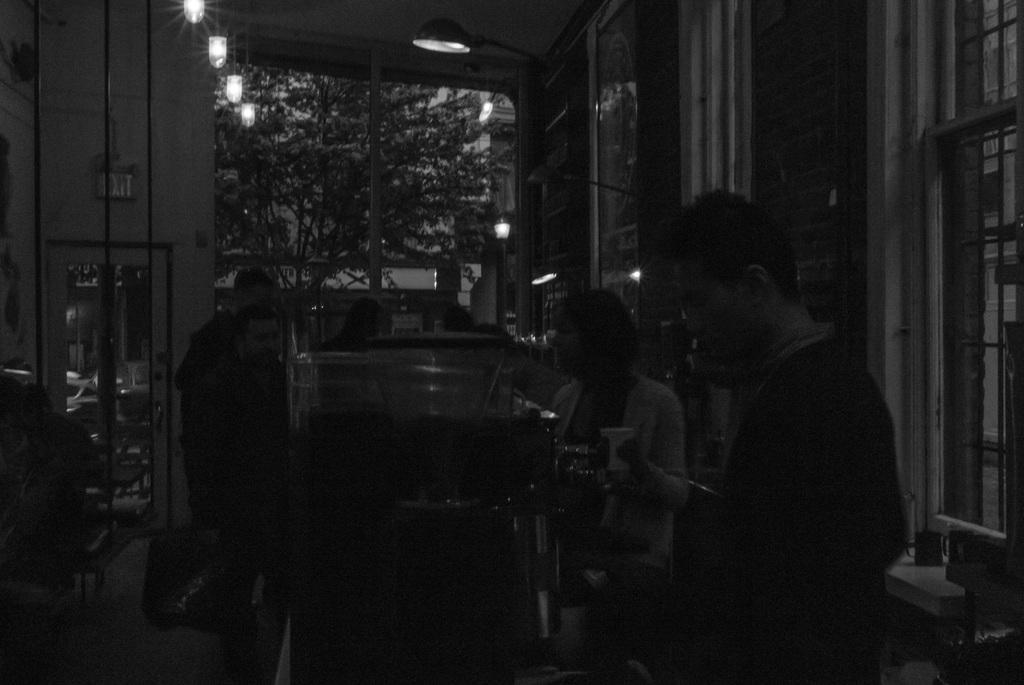How would you summarize this image in a sentence or two? This is a black and white image. In this image we can see tables, chairs, persons, lights, windows, trees and building. 